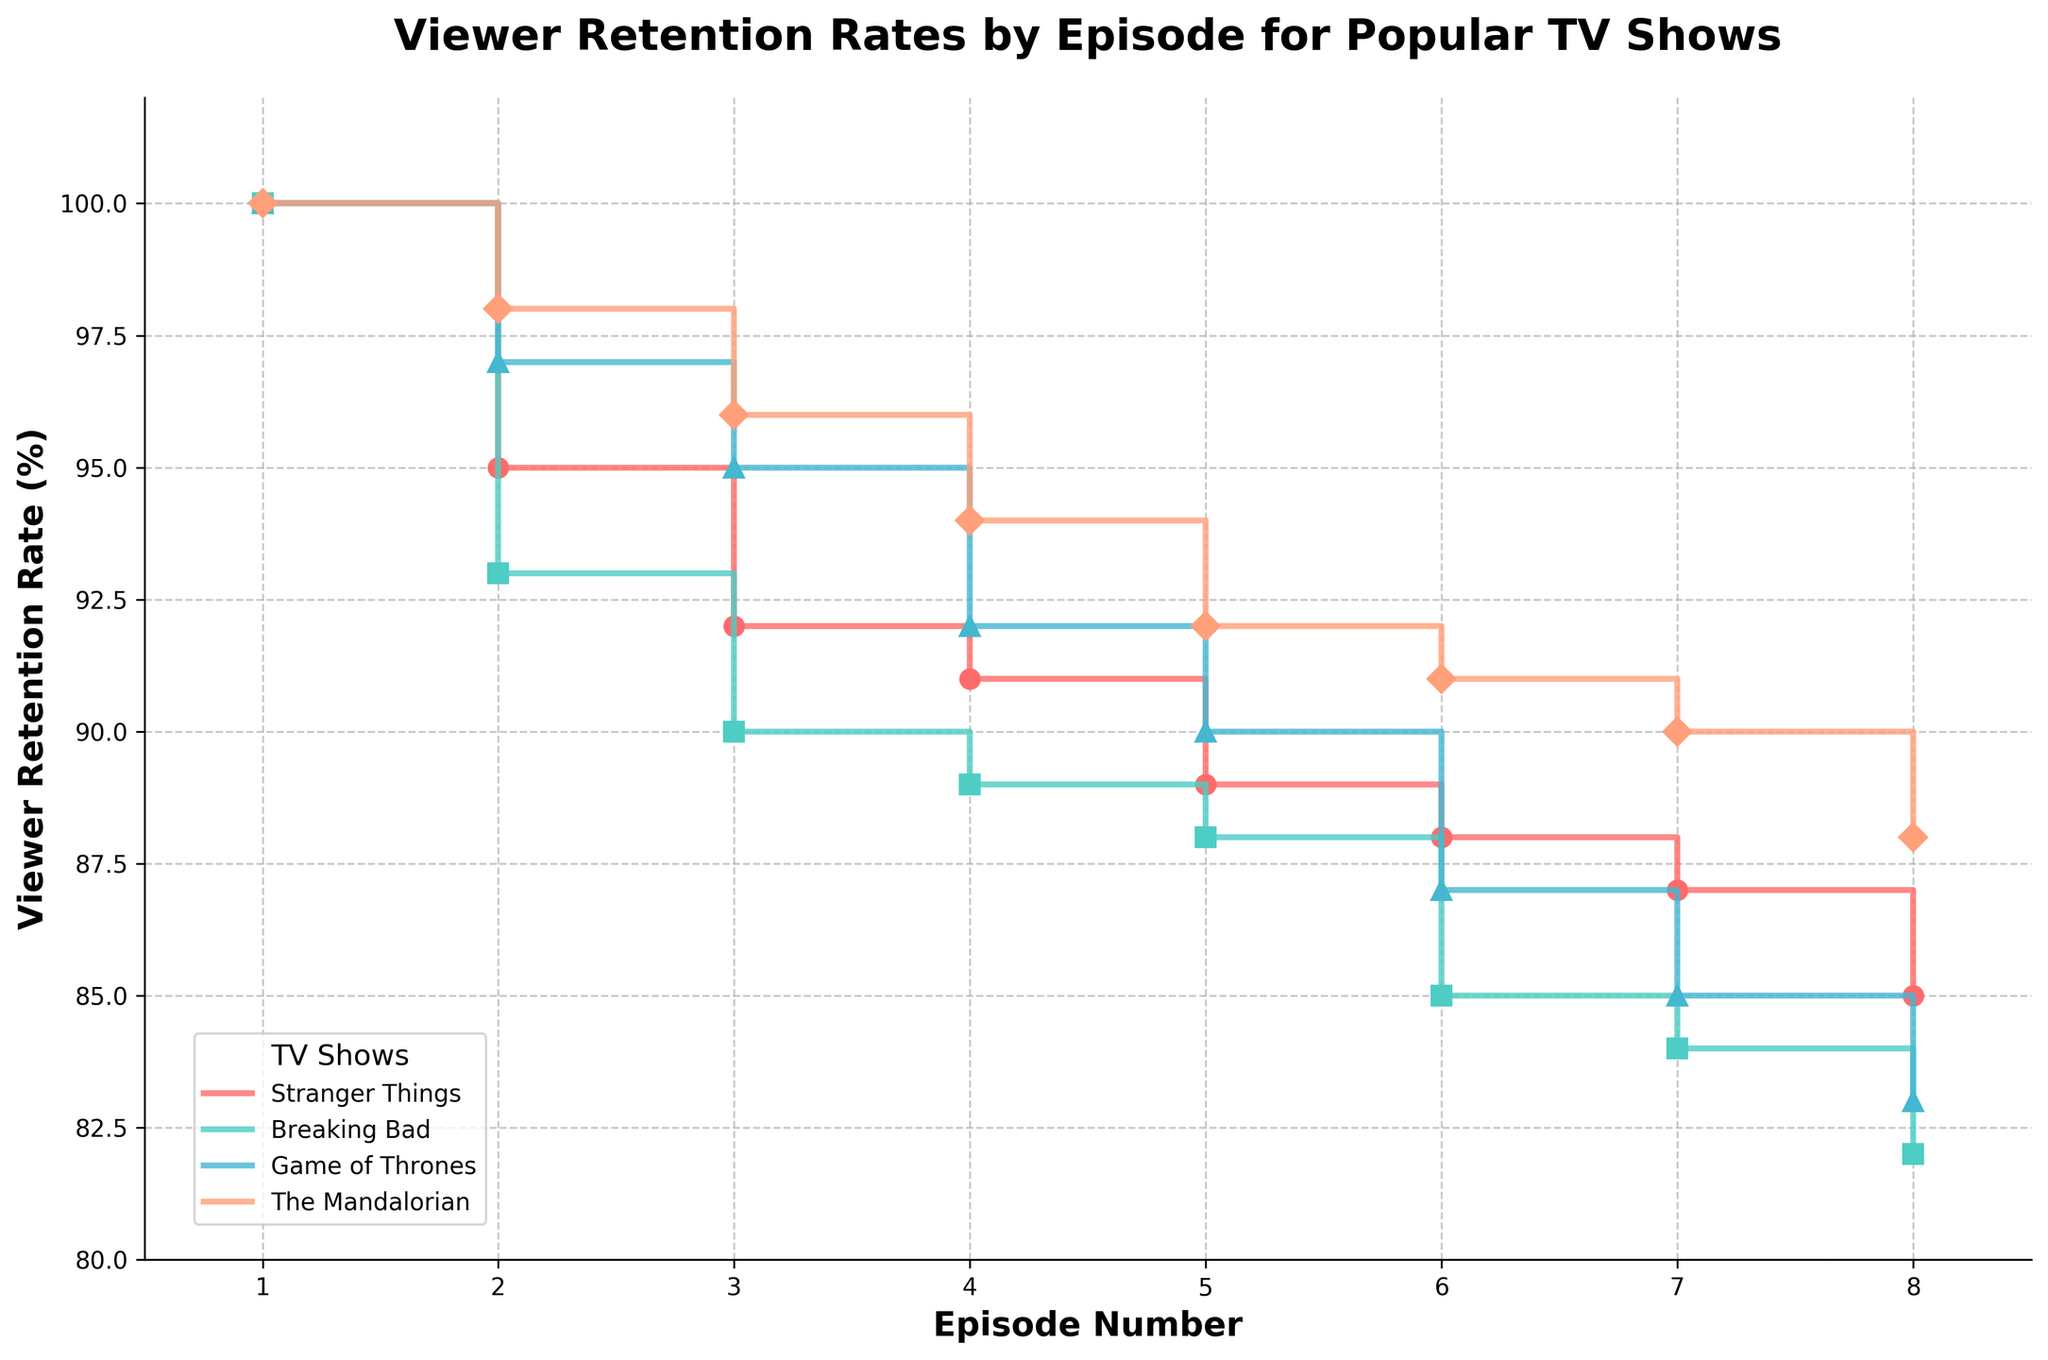What is the title of the plot? The title is displayed at the top of the plot. It reads, "Viewer Retention Rates by Episode for Popular TV Shows."
Answer: Viewer Retention Rates by Episode for Popular TV Shows Which show has the highest viewer retention rate by episode 8? By tracing the lines to Episode 8 and comparing their heights, we see that "Stranger Things" has the highest retention rate at Episode 8 with 85%.
Answer: Stranger Things What is the viewer retention rate for "The Mandalorian" at Episode 4? Follow the "The Mandalorian" line to Episode 4 and note the retention rate, which is marked by a step and a point. It is 94%.
Answer: 94% Which show has the steepest decline in viewer retention rate from Episode 1 to Episode 3? Calculate the difference in viewer retention rates from Episode 1 to Episode 3 for each show, then compare. "Breaking Bad" goes from 100% to 90%, a 10% drop, while other shows have less steep declines.
Answer: Breaking Bad What is the average viewer retention rate of "Game of Thrones" from Episode 1 to Episode 8? Sum the retention rates of episodes 1 through 8 for "Game of Thrones": 100 + 97 + 95 + 92 + 90 + 87 + 85 + 83 = 729. Then divide by 8. Average = 729 / 8 = 91.125.
Answer: 91.125 Which show retains at least 90% of its viewers by Episode 5? Check the retention rates at Episode 5 for all shows. "Stranger Things" (89%), "Breaking Bad" (88%), and "Game of Thrones" (90%) are slightly below 90%. "The Mandalorian" retains 92%. Thus, only "The Mandalorian" retains at least 90% by Episode 5.
Answer: The Mandalorian How does the retention rate of "Stranger Things" at Episode 4 compare to "Game of Thrones" at the same episode? Compare the viewer retention rates at Episode 4 for both shows. "Stranger Things" has 91%, and "Game of Thrones" has 92%. "Game of Thrones" has a slightly higher retention rate.
Answer: Game of Thrones is higher What is the retention rate difference between Episode 3 and Episode 6 for "Breaking Bad"? Subtract the retention rate at Episode 6 from the rate at Episode 3 for "Breaking Bad": 90% (Episode 3) - 85% (Episode 6) = 5%.
Answer: 5% Which show has the smoothest (least varying) retention rate decline over the episodes? Comparing the step heights and smoothness of lines, "The Mandalorian" appears to have the smoothest decline, with smaller incremental drops compared to the other shows.
Answer: The Mandalorian For "Stranger Things", what is the total change in viewer retention rate from Episode 1 to Episode 8? Subtract the retention rate of Episode 8 from Episode 1 for "Stranger Things": 100% (Episode 1) - 85% (Episode 8) = 15%.
Answer: 15% 